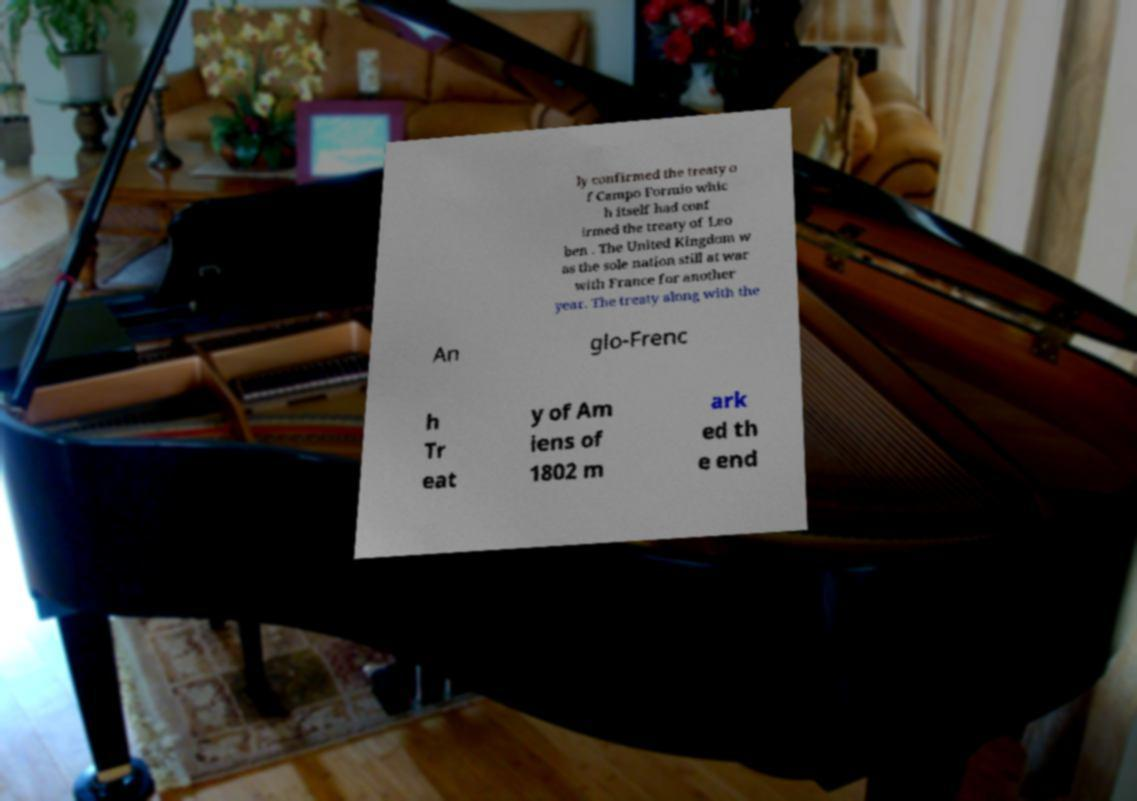There's text embedded in this image that I need extracted. Can you transcribe it verbatim? ly confirmed the treaty o f Campo Formio whic h itself had conf irmed the treaty of Leo ben . The United Kingdom w as the sole nation still at war with France for another year. The treaty along with the An glo-Frenc h Tr eat y of Am iens of 1802 m ark ed th e end 